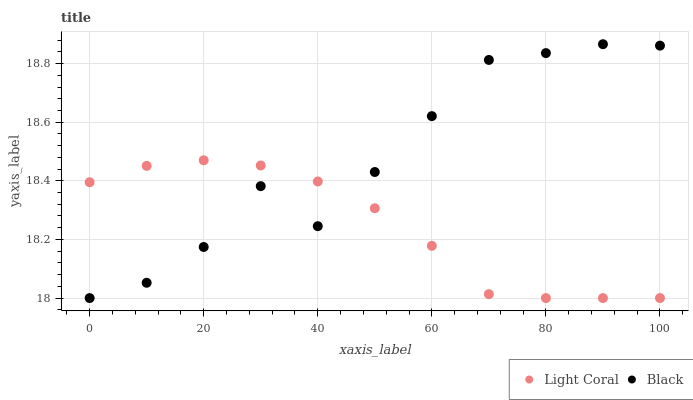Does Light Coral have the minimum area under the curve?
Answer yes or no. Yes. Does Black have the maximum area under the curve?
Answer yes or no. Yes. Does Black have the minimum area under the curve?
Answer yes or no. No. Is Light Coral the smoothest?
Answer yes or no. Yes. Is Black the roughest?
Answer yes or no. Yes. Is Black the smoothest?
Answer yes or no. No. Does Light Coral have the lowest value?
Answer yes or no. Yes. Does Black have the highest value?
Answer yes or no. Yes. Does Black intersect Light Coral?
Answer yes or no. Yes. Is Black less than Light Coral?
Answer yes or no. No. Is Black greater than Light Coral?
Answer yes or no. No. 